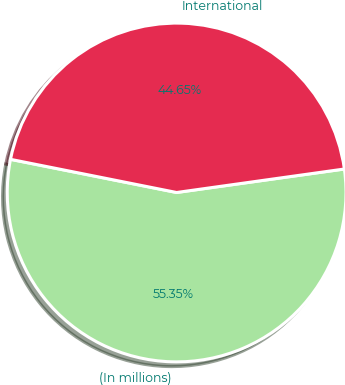Convert chart to OTSL. <chart><loc_0><loc_0><loc_500><loc_500><pie_chart><fcel>(In millions)<fcel>International<nl><fcel>55.35%<fcel>44.65%<nl></chart> 